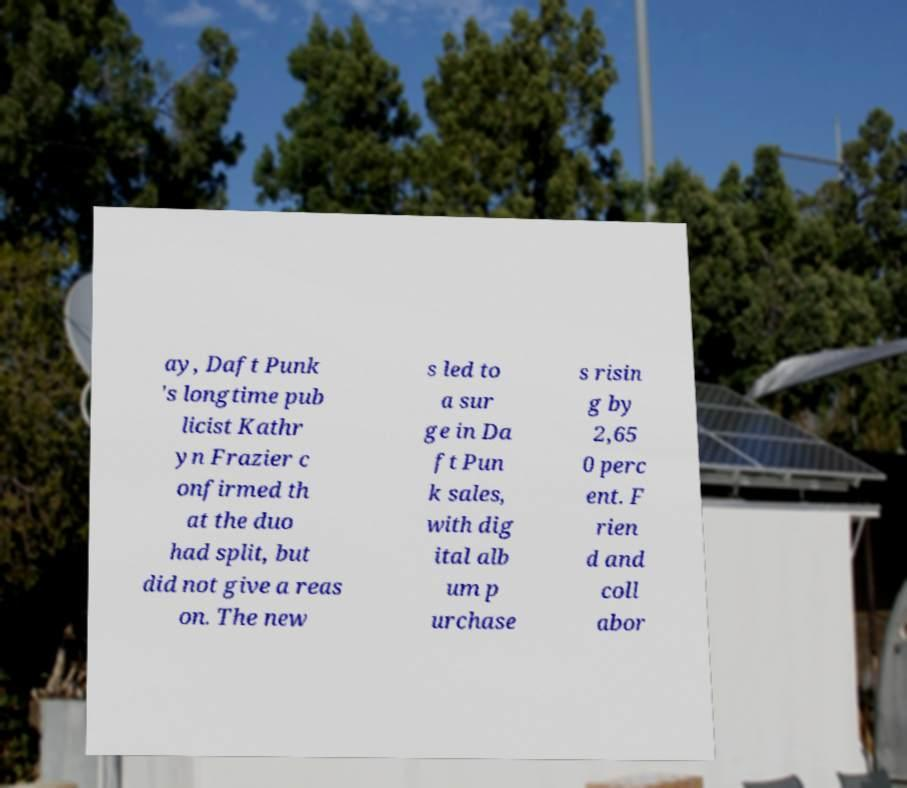I need the written content from this picture converted into text. Can you do that? ay, Daft Punk 's longtime pub licist Kathr yn Frazier c onfirmed th at the duo had split, but did not give a reas on. The new s led to a sur ge in Da ft Pun k sales, with dig ital alb um p urchase s risin g by 2,65 0 perc ent. F rien d and coll abor 